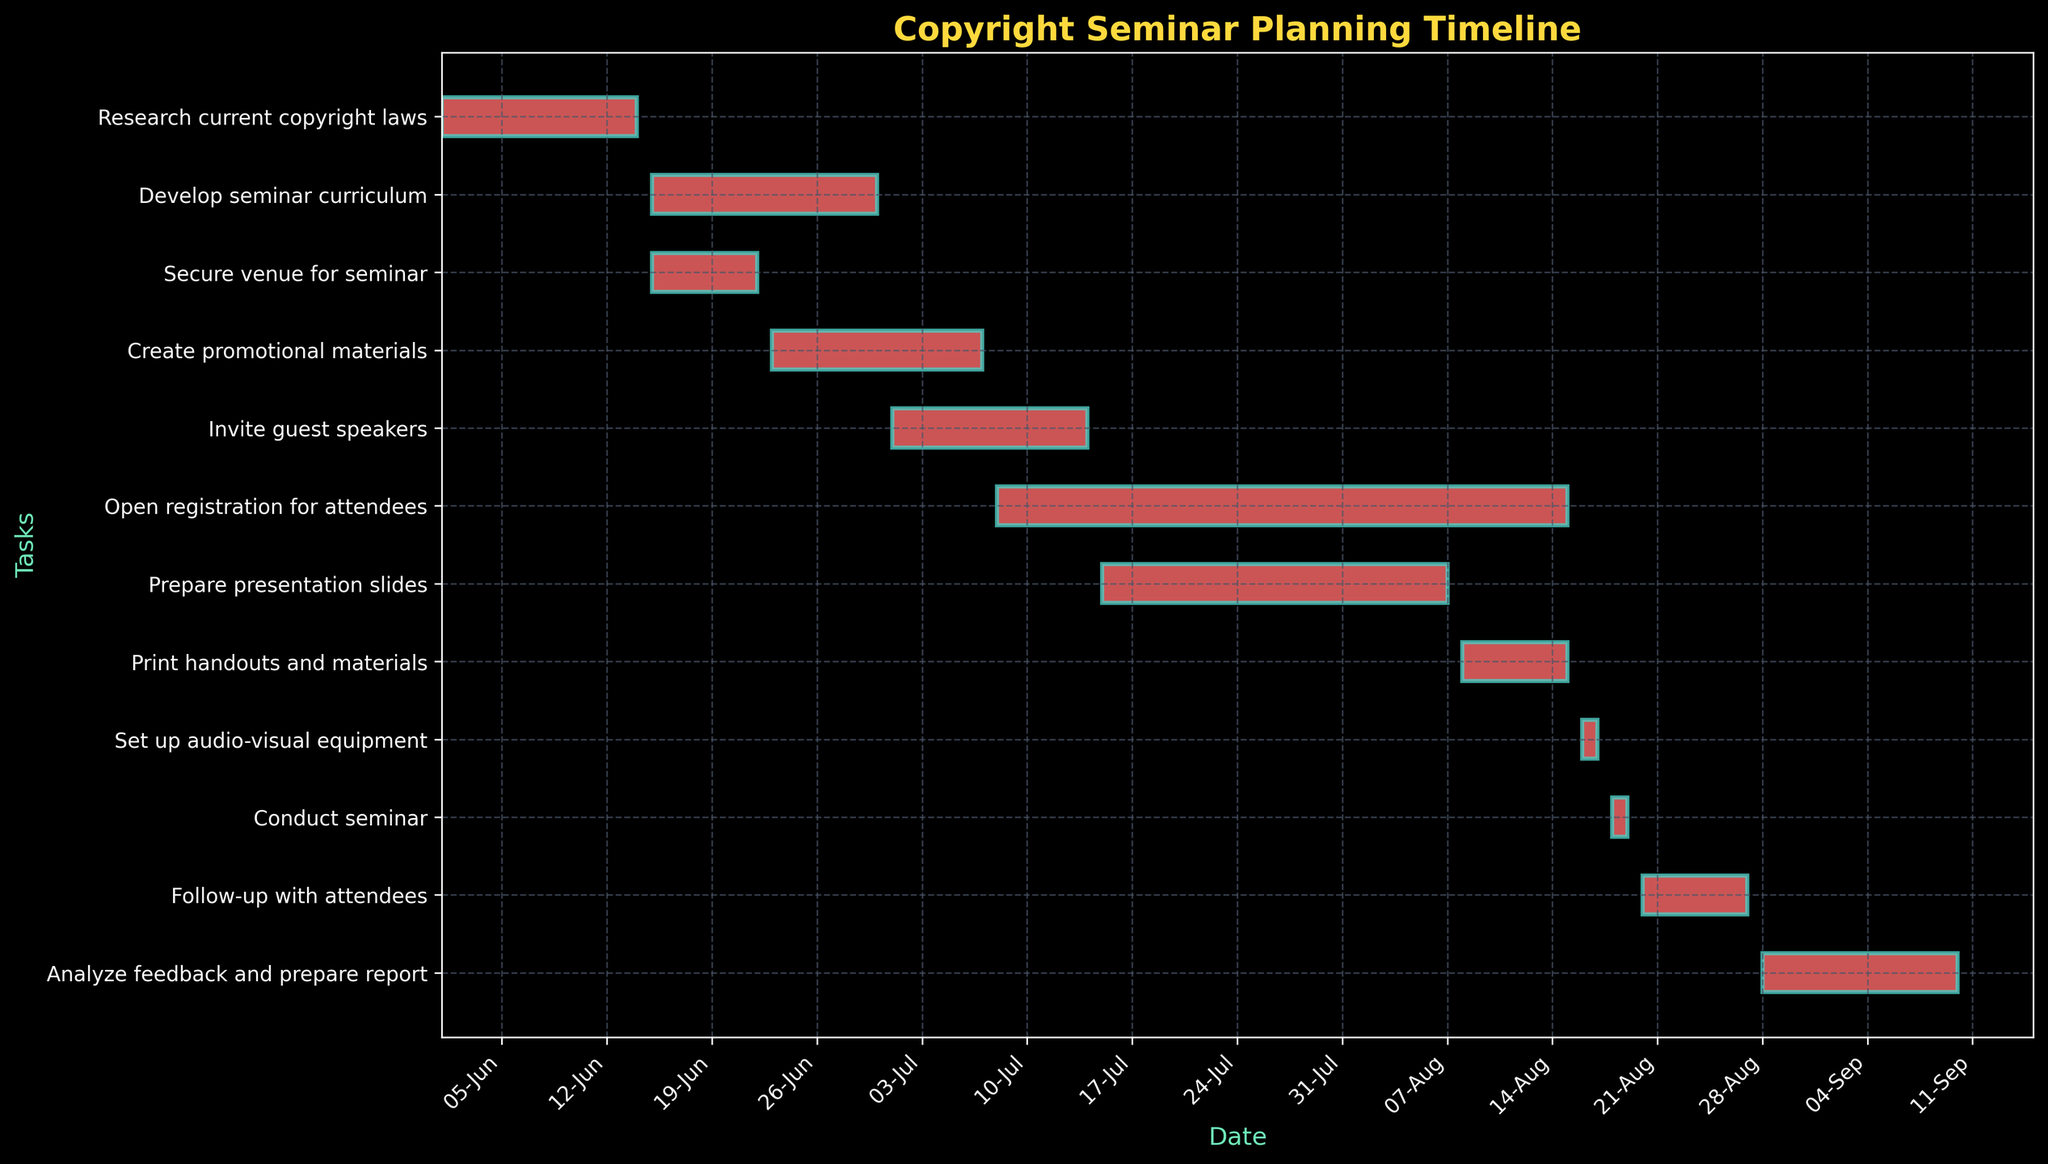What is the title of the Gantt Chart? The title of a Gantt Chart can typically be found at the top of the figure. In this case, the title is clearly labeled on the chart.
Answer: Copyright Seminar Planning Timeline When does the "Develop seminar curriculum" task start and end? To find the start and end dates of any task, you need to locate the task's bar on the Gantt Chart and read the dates indicated at the start and end points of the bar.
Answer: 2023-06-15 to 2023-06-30 How long is the "Create promotional materials" task scheduled to last? To determine the duration of a task, find the start and end dates, then calculate the difference in days between these dates. The "Create promotional materials" task starts on 2023-06-23 and ends on 2023-07-07. The duration is 14 days.
Answer: 14 days Which task immediately follows "Print handouts and materials"? By examining the Gantt Chart, the tasks are plotted in sequence. The task that starts right after "Print handouts and materials" is "Set up audio-visual equipment".
Answer: Set up audio-visual equipment Is the "Secure venue for seminar" task overlapping with the "Develop seminar curriculum" task? To check if two tasks overlap, visually inspect their bars on the Gantt Chart. Both tasks start on 2023-06-15, with "Secure venue for seminar" ending on 2023-06-22 and "Develop seminar curriculum" ending on 2023-06-30. They do overlap between 2023-06-15 and 2023-06-22.
Answer: Yes How many days in total does it take to "Open registration for attendees" and "Prepare presentation slides" combined? Find the duration of each task separately then add them together. "Open registration for attendees" lasts from 2023-07-08 to 2023-08-15 (38 days), and "Prepare presentation slides" lasts from 2023-07-15 to 2023-08-07 (24 days). 38 + 24 = 62 days.
Answer: 62 days Which task has the longest duration? To find the task with the longest duration, visually compare the lengths of all the bars or calculate the duration of each task by subtracting the start date from the end date for each. The "Open registration for attendees" task has the longest duration from 2023-07-08 to 2023-08-15, which is 38 days.
Answer: Open registration for attendees What is the relationship between the tasks "Set up audio-visual equipment" and "Conduct seminar"? Look at the sequence and alignment of the tasks. "Set up audio-visual equipment" is scheduled for 2023-08-16 to 2023-08-17 and is directly followed by "Conduct seminar" on 2023-08-18 to 2023-08-19, indicating that one task must be completed before the other can begin.
Answer: Sequential (Set up audio-visual equipment precedes Conduct seminar) How many tasks are planned after "Create promotional materials"? To answer this, count the number of tasks that are scheduled to begin after the "Create promotional materials" task ends on 2023-07-07. There are six tasks: "Invite guest speakers", "Open registration for attendees", "Prepare presentation slides", "Print handouts and materials", "Set up audio-visual equipment", "Conduct seminar", and "Follow-up with attendees".
Answer: 7 tasks What is the total duration from the start of "Research current copyright laws" to the end of "Analyze feedback and prepare report"? This involves calculating the time from the start date of the first task to the end date of the last task in the chart. "Research current copyright laws" starts on 2023-06-01 and "Analyze feedback and prepare report" ends on 2023-09-10, which is a span of 101 days.
Answer: 101 days 